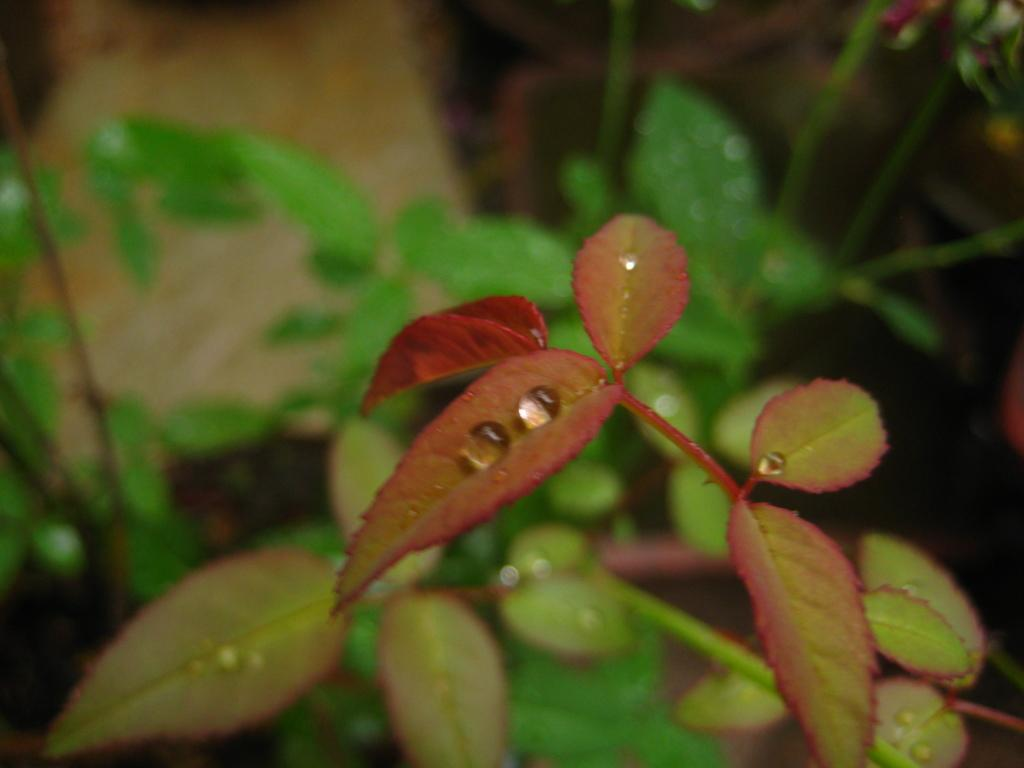What type of vegetation is present in the image? There are plant leaves in the image. What can be seen on the plant leaves? There are water droplets in the image. How would you describe the background of the image? The background of the image is blurred. What type of hook is used to pick the berries in the image? There are no berries or hooks present in the image. 